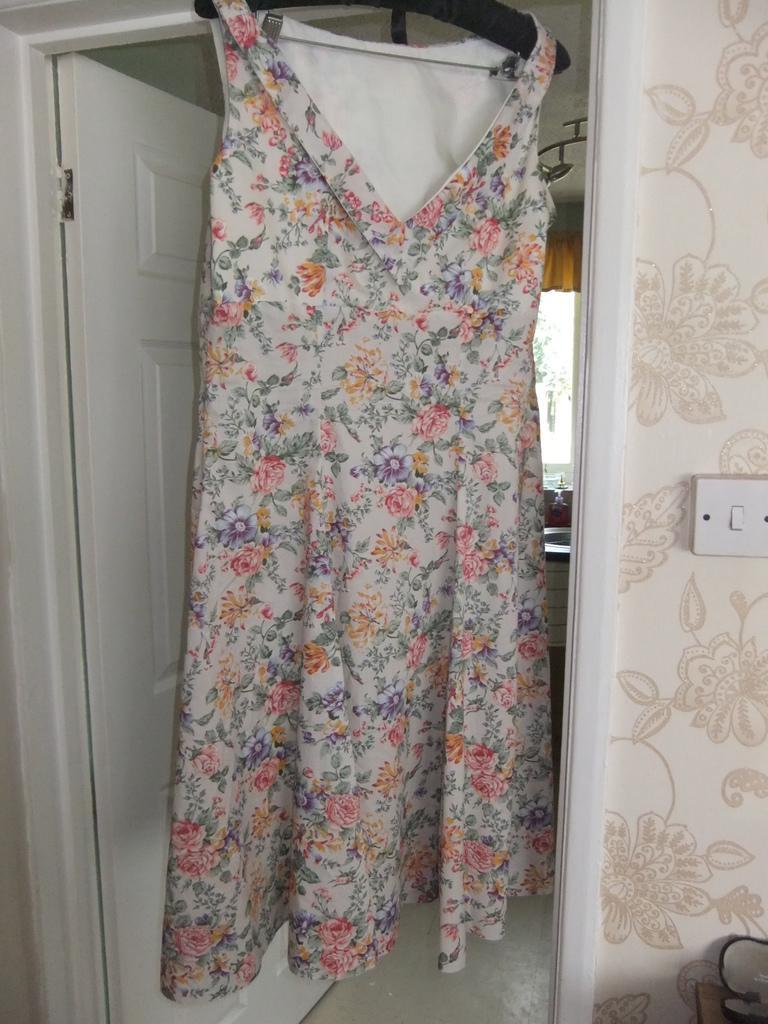Could you give a brief overview of what you see in this image? This picture might be taken inside the room. In this image, in the middle, we can see a dress with hanger. On the left side, we can see a door which is in white color. On the right side, we can see a switch and a wall. On the right corner, we can see a table and a box. In the background, we can see a wash basin, glass window and curtains. On the top, we can see a roof. 